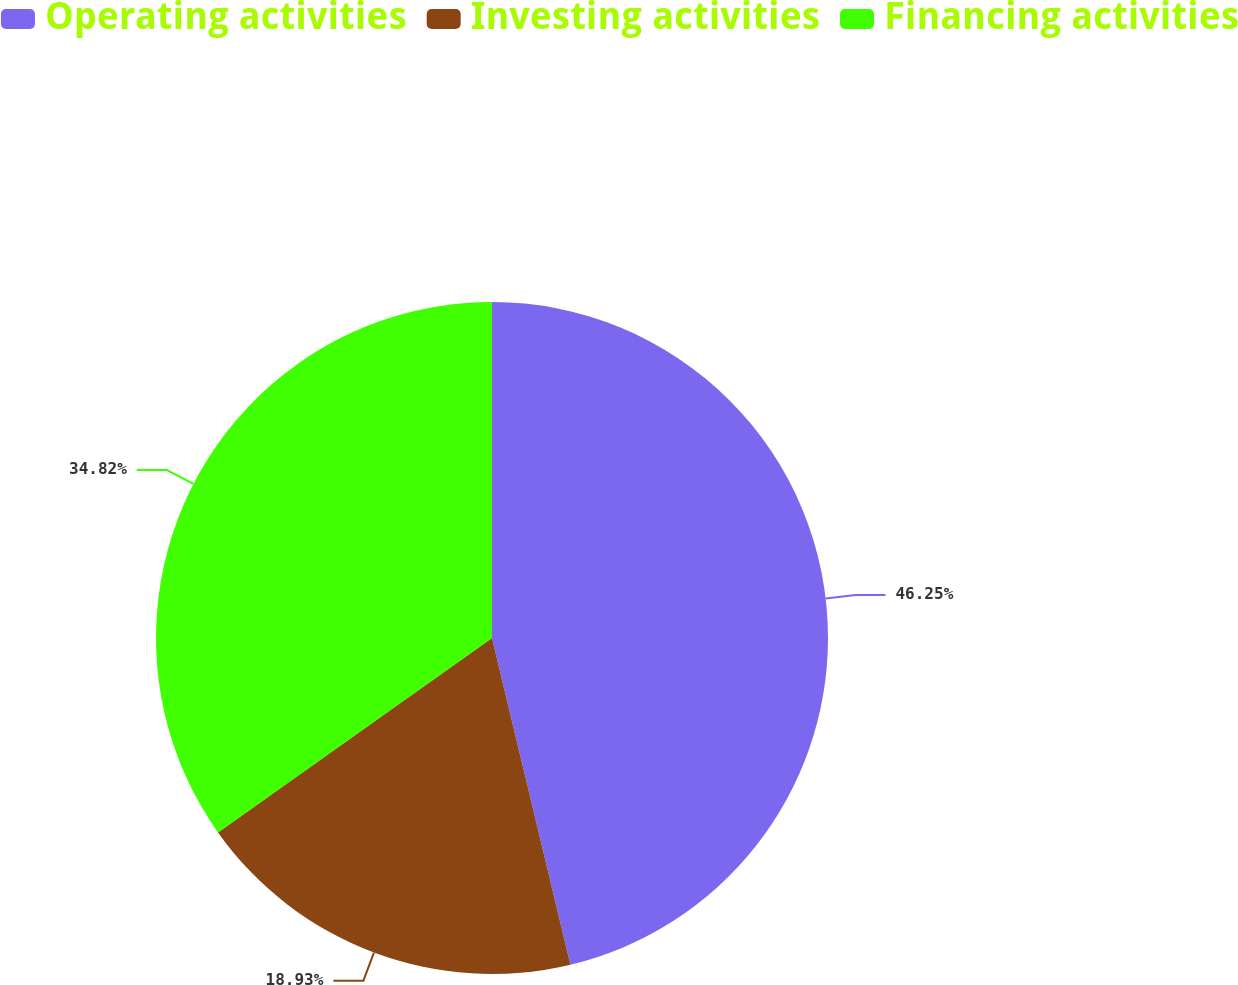<chart> <loc_0><loc_0><loc_500><loc_500><pie_chart><fcel>Operating activities<fcel>Investing activities<fcel>Financing activities<nl><fcel>46.25%<fcel>18.93%<fcel>34.82%<nl></chart> 